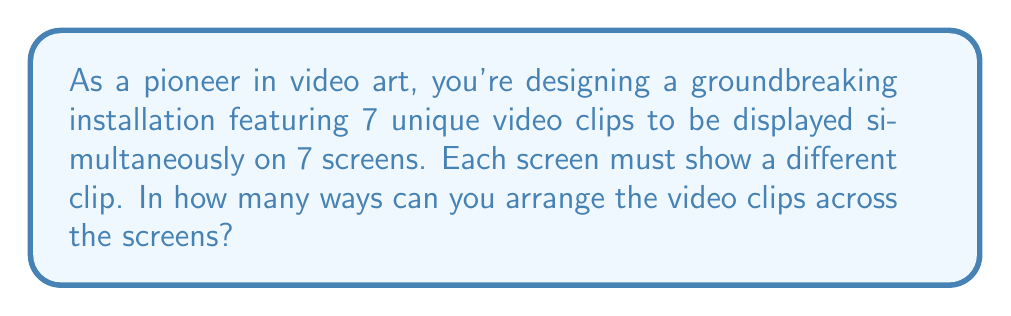Could you help me with this problem? Let's approach this step-by-step:

1) This problem is a classic permutation scenario. We have 7 distinct video clips (objects) to be arranged in 7 distinct positions (screens).

2) In permutation problems, the order matters. Each screen must show a different clip, so we're essentially creating a one-to-one correspondence between clips and screens.

3) For the first screen, we have 7 choices of clips.

4) For the second screen, we have 6 remaining choices.

5) For the third screen, we have 5 choices, and so on.

6) This continues until we reach the last screen, where we have only 1 choice left.

7) The total number of possible arrangements is the product of all these choices:

   $$7 \times 6 \times 5 \times 4 \times 3 \times 2 \times 1$$

8) This is the definition of 7 factorial, denoted as 7!

9) Therefore, the number of possible arrangements is:

   $$7! = 7 \times 6 \times 5 \times 4 \times 3 \times 2 \times 1 = 5040$$

This calculation gives us the total number of ways to arrange 7 distinct video clips on 7 distinct screens.
Answer: 5040 